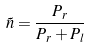Convert formula to latex. <formula><loc_0><loc_0><loc_500><loc_500>\tilde { n } = \frac { P _ { r } } { P _ { r } + P _ { l } }</formula> 